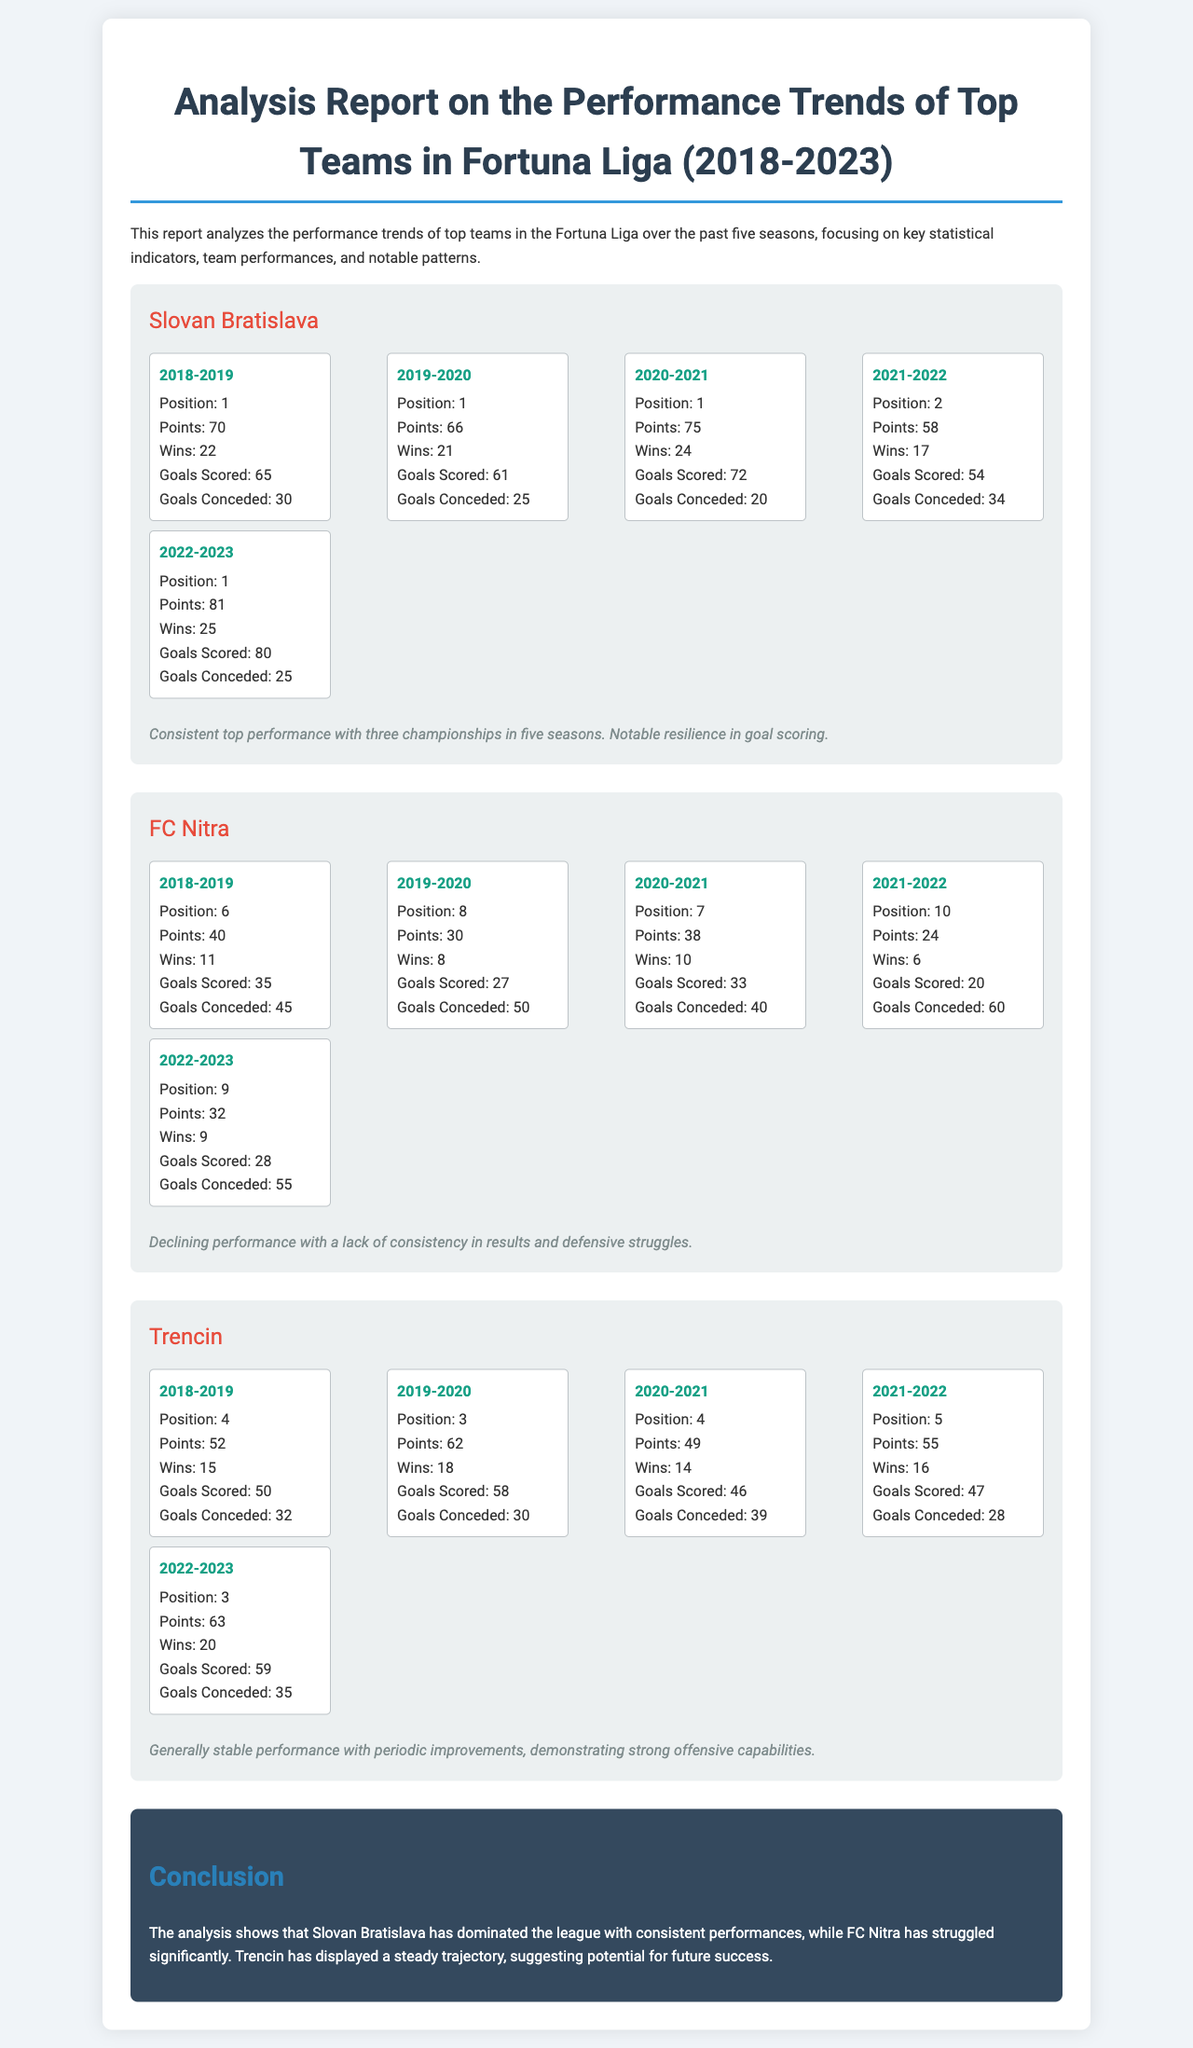What position did Slovan Bratislava achieve in the 2020-2021 season? The position listed for Slovan Bratislava in the 2020-2021 season is 1.
Answer: 1 How many points did FC Nitra earn in the 2021-2022 season? The total points earned by FC Nitra in the 2021-2022 season are stated as 24.
Answer: 24 Which team scored the most goals in the 2022-2023 season? The document indicates that Slovan Bratislava scored 80 goals in the 2022-2023 season.
Answer: Slovan Bratislava What has been the trend for FC Nitra over the past five seasons? The trend describes FC Nitra as having declining performance with a lack of consistency in results.
Answer: Declining performance What is the total number of championships won by Slovan Bratislava in five seasons? The report notes that Slovan Bratislava achieved three championships in five seasons.
Answer: Three championships In which season did Trencin score the highest number of goals? Trencin's highest goals scored is from the 2022-2023 season, where they achieved 59 goals.
Answer: 59 goals Which team had the lowest points in the 2021-2022 season? The document states that FC Nitra had the lowest points in that season, with 24 points.
Answer: FC Nitra What is the color of the team names in the report? The team names are colored in red as indicated in the document's styling.
Answer: Red 